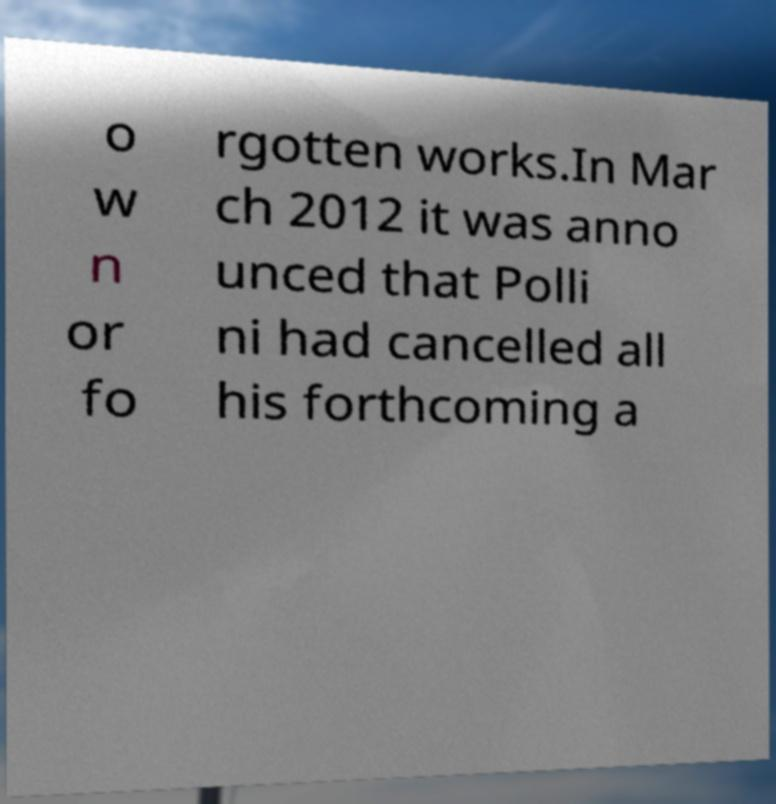What messages or text are displayed in this image? I need them in a readable, typed format. o w n or fo rgotten works.In Mar ch 2012 it was anno unced that Polli ni had cancelled all his forthcoming a 